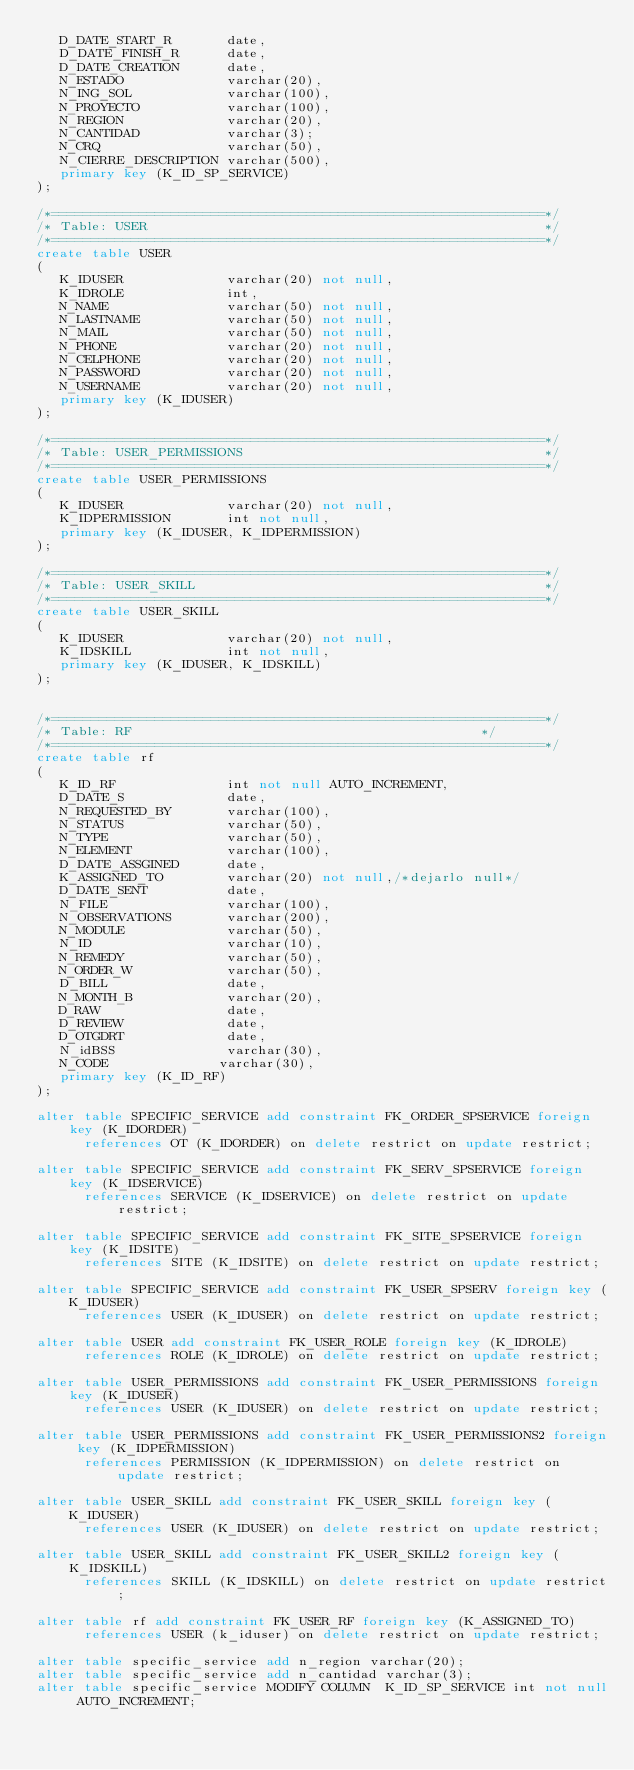<code> <loc_0><loc_0><loc_500><loc_500><_SQL_>   D_DATE_START_R       date,
   D_DATE_FINISH_R      date,
   D_DATE_CREATION      date,
   N_ESTADO             varchar(20),
   N_ING_SOL            varchar(100),
   N_PROYECTO           varchar(100),
   N_REGION             varchar(20),
   N_CANTIDAD           varchar(3);
   N_CRQ                varchar(50),
   N_CIERRE_DESCRIPTION varchar(500),
   primary key (K_ID_SP_SERVICE)
);

/*==============================================================*/
/* Table: USER                                                  */
/*==============================================================*/
create table USER
(
   K_IDUSER             varchar(20) not null,
   K_IDROLE             int,
   N_NAME               varchar(50) not null,
   N_LASTNAME           varchar(50) not null,
   N_MAIL               varchar(50) not null,
   N_PHONE              varchar(20) not null,
   N_CELPHONE           varchar(20) not null,
   N_PASSWORD           varchar(20) not null,
   N_USERNAME           varchar(20) not null,
   primary key (K_IDUSER)
);

/*==============================================================*/
/* Table: USER_PERMISSIONS                                      */
/*==============================================================*/
create table USER_PERMISSIONS
(
   K_IDUSER             varchar(20) not null,
   K_IDPERMISSION       int not null,
   primary key (K_IDUSER, K_IDPERMISSION)
);

/*==============================================================*/
/* Table: USER_SKILL                                            */
/*==============================================================*/
create table USER_SKILL
(
   K_IDUSER             varchar(20) not null,
   K_IDSKILL            int not null,
   primary key (K_IDUSER, K_IDSKILL)
);


/*==============================================================*/
/* Table: RF                                            */
/*==============================================================*/
create table rf
(
   K_ID_RF              int not null AUTO_INCREMENT,
   D_DATE_S             date,
   N_REQUESTED_BY       varchar(100),
   N_STATUS             varchar(50),
   N_TYPE               varchar(50),
   N_ELEMENT            varchar(100),
   D_DATE_ASSGINED      date,
   K_ASSIGNED_TO        varchar(20) not null,/*dejarlo null*/
   D_DATE_SENT          date,
   N_FILE               varchar(100),
   N_OBSERVATIONS       varchar(200),
   N_MODULE             varchar(50),
   N_ID                 varchar(10),
   N_REMEDY             varchar(50),
   N_ORDER_W            varchar(50),
   D_BILL               date,
   N_MONTH_B            varchar(20),
   D_RAW                date,
   D_REVIEW             date,
   D_OTGDRT             date,
   N_idBSS              varchar(30),
   N_CODE              varchar(30),
   primary key (K_ID_RF)
);

alter table SPECIFIC_SERVICE add constraint FK_ORDER_SPSERVICE foreign key (K_IDORDER)
      references OT (K_IDORDER) on delete restrict on update restrict;

alter table SPECIFIC_SERVICE add constraint FK_SERV_SPSERVICE foreign key (K_IDSERVICE)
      references SERVICE (K_IDSERVICE) on delete restrict on update restrict;

alter table SPECIFIC_SERVICE add constraint FK_SITE_SPSERVICE foreign key (K_IDSITE)
      references SITE (K_IDSITE) on delete restrict on update restrict;

alter table SPECIFIC_SERVICE add constraint FK_USER_SPSERV foreign key (K_IDUSER)
      references USER (K_IDUSER) on delete restrict on update restrict;

alter table USER add constraint FK_USER_ROLE foreign key (K_IDROLE)
      references ROLE (K_IDROLE) on delete restrict on update restrict;

alter table USER_PERMISSIONS add constraint FK_USER_PERMISSIONS foreign key (K_IDUSER)
      references USER (K_IDUSER) on delete restrict on update restrict;

alter table USER_PERMISSIONS add constraint FK_USER_PERMISSIONS2 foreign key (K_IDPERMISSION)
      references PERMISSION (K_IDPERMISSION) on delete restrict on update restrict;

alter table USER_SKILL add constraint FK_USER_SKILL foreign key (K_IDUSER)
      references USER (K_IDUSER) on delete restrict on update restrict;

alter table USER_SKILL add constraint FK_USER_SKILL2 foreign key (K_IDSKILL)
      references SKILL (K_IDSKILL) on delete restrict on update restrict;

alter table rf add constraint FK_USER_RF foreign key (K_ASSIGNED_TO)
      references USER (k_iduser) on delete restrict on update restrict;

alter table specific_service add n_region varchar(20);
alter table specific_service add n_cantidad varchar(3);
alter table specific_service MODIFY COLUMN  K_ID_SP_SERVICE int not null AUTO_INCREMENT;
</code> 